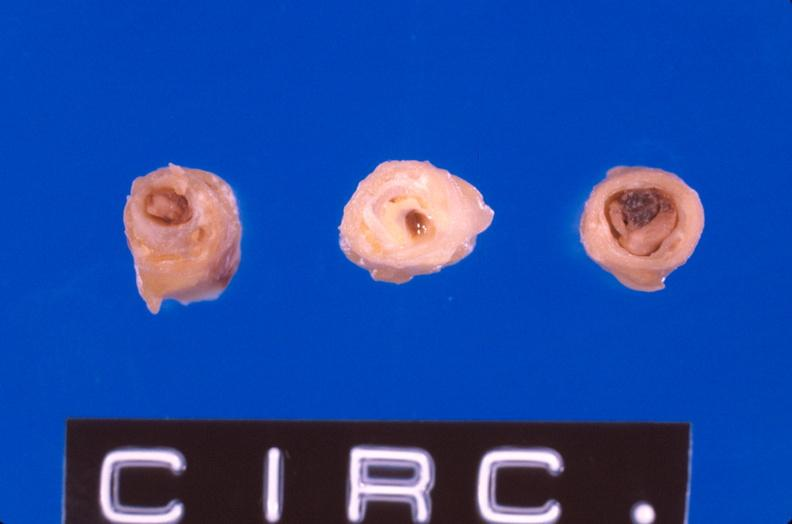s this present?
Answer the question using a single word or phrase. No 